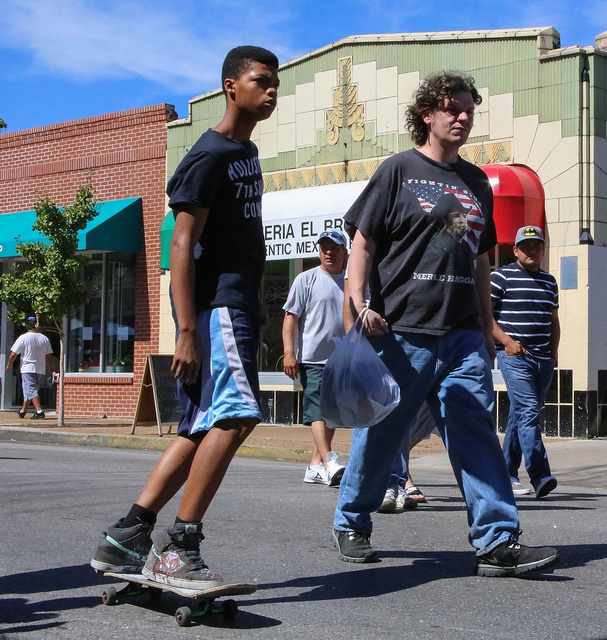Describe the objects in this image and their specific colors. I can see people in lightblue, black, gray, and navy tones, people in lightblue, black, darkgray, brown, and gray tones, people in lightblue, black, navy, gray, and darkblue tones, people in lightblue, gray, lavender, black, and darkgray tones, and skateboard in lightblue, black, darkgray, gray, and lavender tones in this image. 